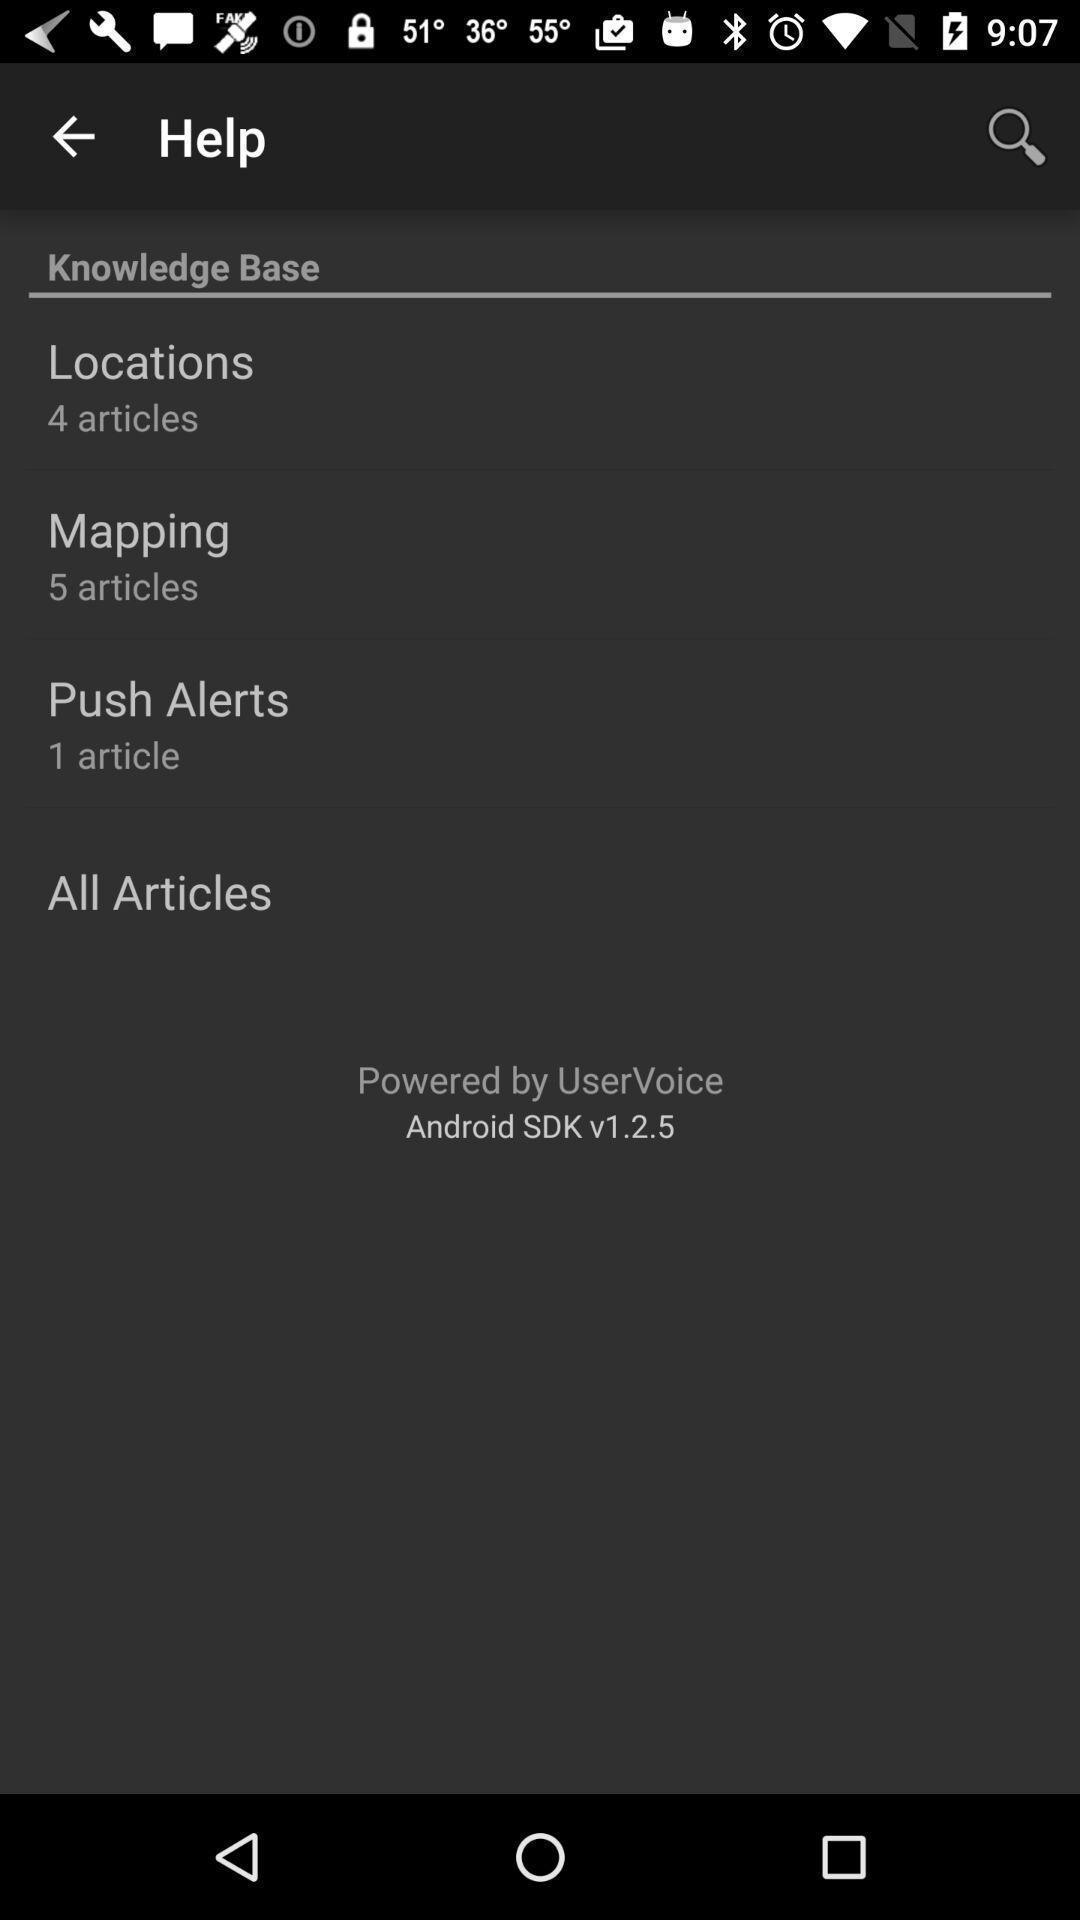Tell me what you see in this picture. Weather app displayed help page. 